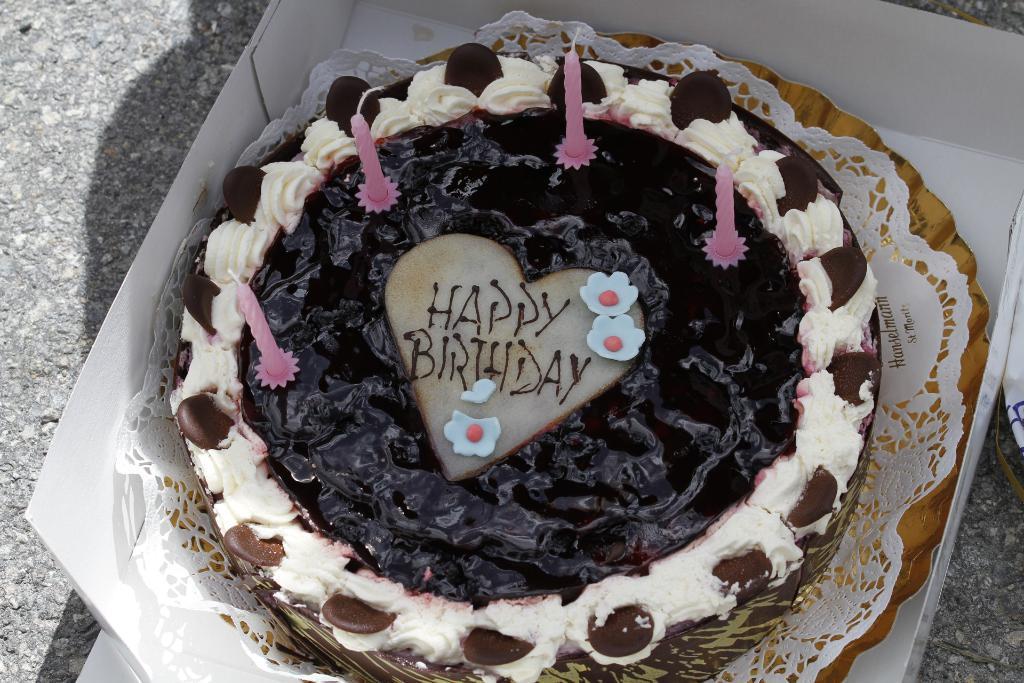Please provide a concise description of this image. This image is taken outdoors. On the left side of the image there is a road. In the middle of the image there is a cake with candles and cream on the tray. The tray is kept in the cardboard box. 